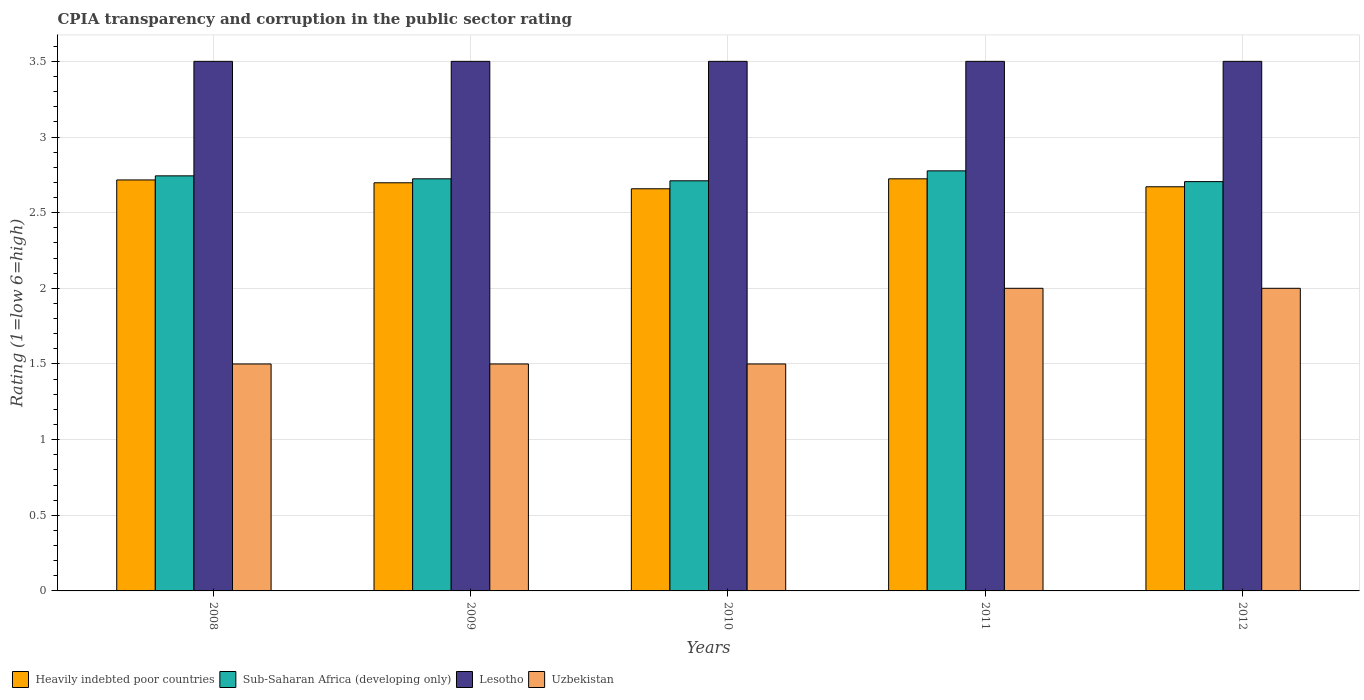How many bars are there on the 1st tick from the left?
Your answer should be compact. 4. How many bars are there on the 2nd tick from the right?
Your response must be concise. 4. What is the label of the 5th group of bars from the left?
Provide a short and direct response. 2012. What is the CPIA rating in Sub-Saharan Africa (developing only) in 2010?
Offer a very short reply. 2.71. Across all years, what is the maximum CPIA rating in Uzbekistan?
Give a very brief answer. 2. Across all years, what is the minimum CPIA rating in Uzbekistan?
Your answer should be very brief. 1.5. In which year was the CPIA rating in Heavily indebted poor countries maximum?
Provide a short and direct response. 2011. In which year was the CPIA rating in Lesotho minimum?
Provide a succinct answer. 2008. What is the total CPIA rating in Sub-Saharan Africa (developing only) in the graph?
Provide a short and direct response. 13.66. What is the difference between the CPIA rating in Lesotho in 2009 and that in 2010?
Your answer should be compact. 0. What is the difference between the CPIA rating in Uzbekistan in 2010 and the CPIA rating in Heavily indebted poor countries in 2012?
Provide a succinct answer. -1.17. What is the average CPIA rating in Heavily indebted poor countries per year?
Offer a terse response. 2.69. In the year 2012, what is the difference between the CPIA rating in Lesotho and CPIA rating in Heavily indebted poor countries?
Ensure brevity in your answer.  0.83. What is the ratio of the CPIA rating in Heavily indebted poor countries in 2010 to that in 2011?
Ensure brevity in your answer.  0.98. Is the difference between the CPIA rating in Lesotho in 2010 and 2012 greater than the difference between the CPIA rating in Heavily indebted poor countries in 2010 and 2012?
Give a very brief answer. Yes. What is the difference between the highest and the second highest CPIA rating in Heavily indebted poor countries?
Ensure brevity in your answer.  0.01. What is the difference between the highest and the lowest CPIA rating in Uzbekistan?
Ensure brevity in your answer.  0.5. Is it the case that in every year, the sum of the CPIA rating in Heavily indebted poor countries and CPIA rating in Lesotho is greater than the sum of CPIA rating in Uzbekistan and CPIA rating in Sub-Saharan Africa (developing only)?
Your answer should be compact. Yes. What does the 3rd bar from the left in 2008 represents?
Provide a succinct answer. Lesotho. What does the 4th bar from the right in 2010 represents?
Offer a very short reply. Heavily indebted poor countries. How many bars are there?
Your answer should be very brief. 20. Where does the legend appear in the graph?
Keep it short and to the point. Bottom left. How many legend labels are there?
Provide a short and direct response. 4. How are the legend labels stacked?
Ensure brevity in your answer.  Horizontal. What is the title of the graph?
Provide a succinct answer. CPIA transparency and corruption in the public sector rating. Does "Bangladesh" appear as one of the legend labels in the graph?
Offer a very short reply. No. What is the label or title of the X-axis?
Provide a short and direct response. Years. What is the Rating (1=low 6=high) in Heavily indebted poor countries in 2008?
Keep it short and to the point. 2.72. What is the Rating (1=low 6=high) of Sub-Saharan Africa (developing only) in 2008?
Keep it short and to the point. 2.74. What is the Rating (1=low 6=high) of Heavily indebted poor countries in 2009?
Ensure brevity in your answer.  2.7. What is the Rating (1=low 6=high) of Sub-Saharan Africa (developing only) in 2009?
Your answer should be compact. 2.72. What is the Rating (1=low 6=high) of Lesotho in 2009?
Offer a very short reply. 3.5. What is the Rating (1=low 6=high) of Uzbekistan in 2009?
Offer a terse response. 1.5. What is the Rating (1=low 6=high) in Heavily indebted poor countries in 2010?
Ensure brevity in your answer.  2.66. What is the Rating (1=low 6=high) of Sub-Saharan Africa (developing only) in 2010?
Ensure brevity in your answer.  2.71. What is the Rating (1=low 6=high) of Heavily indebted poor countries in 2011?
Your response must be concise. 2.72. What is the Rating (1=low 6=high) in Sub-Saharan Africa (developing only) in 2011?
Your answer should be very brief. 2.78. What is the Rating (1=low 6=high) in Heavily indebted poor countries in 2012?
Offer a very short reply. 2.67. What is the Rating (1=low 6=high) of Sub-Saharan Africa (developing only) in 2012?
Provide a short and direct response. 2.71. What is the Rating (1=low 6=high) in Lesotho in 2012?
Make the answer very short. 3.5. Across all years, what is the maximum Rating (1=low 6=high) in Heavily indebted poor countries?
Provide a short and direct response. 2.72. Across all years, what is the maximum Rating (1=low 6=high) of Sub-Saharan Africa (developing only)?
Make the answer very short. 2.78. Across all years, what is the maximum Rating (1=low 6=high) of Lesotho?
Provide a succinct answer. 3.5. Across all years, what is the minimum Rating (1=low 6=high) in Heavily indebted poor countries?
Keep it short and to the point. 2.66. Across all years, what is the minimum Rating (1=low 6=high) in Sub-Saharan Africa (developing only)?
Give a very brief answer. 2.71. Across all years, what is the minimum Rating (1=low 6=high) in Lesotho?
Your answer should be very brief. 3.5. Across all years, what is the minimum Rating (1=low 6=high) in Uzbekistan?
Ensure brevity in your answer.  1.5. What is the total Rating (1=low 6=high) of Heavily indebted poor countries in the graph?
Make the answer very short. 13.47. What is the total Rating (1=low 6=high) in Sub-Saharan Africa (developing only) in the graph?
Offer a terse response. 13.66. What is the total Rating (1=low 6=high) of Uzbekistan in the graph?
Ensure brevity in your answer.  8.5. What is the difference between the Rating (1=low 6=high) in Heavily indebted poor countries in 2008 and that in 2009?
Offer a terse response. 0.02. What is the difference between the Rating (1=low 6=high) in Sub-Saharan Africa (developing only) in 2008 and that in 2009?
Offer a terse response. 0.02. What is the difference between the Rating (1=low 6=high) of Lesotho in 2008 and that in 2009?
Ensure brevity in your answer.  0. What is the difference between the Rating (1=low 6=high) of Heavily indebted poor countries in 2008 and that in 2010?
Give a very brief answer. 0.06. What is the difference between the Rating (1=low 6=high) in Sub-Saharan Africa (developing only) in 2008 and that in 2010?
Make the answer very short. 0.03. What is the difference between the Rating (1=low 6=high) in Lesotho in 2008 and that in 2010?
Make the answer very short. 0. What is the difference between the Rating (1=low 6=high) in Uzbekistan in 2008 and that in 2010?
Make the answer very short. 0. What is the difference between the Rating (1=low 6=high) in Heavily indebted poor countries in 2008 and that in 2011?
Offer a very short reply. -0.01. What is the difference between the Rating (1=low 6=high) of Sub-Saharan Africa (developing only) in 2008 and that in 2011?
Offer a very short reply. -0.03. What is the difference between the Rating (1=low 6=high) in Lesotho in 2008 and that in 2011?
Offer a terse response. 0. What is the difference between the Rating (1=low 6=high) in Uzbekistan in 2008 and that in 2011?
Provide a succinct answer. -0.5. What is the difference between the Rating (1=low 6=high) in Heavily indebted poor countries in 2008 and that in 2012?
Provide a short and direct response. 0.05. What is the difference between the Rating (1=low 6=high) in Sub-Saharan Africa (developing only) in 2008 and that in 2012?
Your response must be concise. 0.04. What is the difference between the Rating (1=low 6=high) in Heavily indebted poor countries in 2009 and that in 2010?
Give a very brief answer. 0.04. What is the difference between the Rating (1=low 6=high) of Sub-Saharan Africa (developing only) in 2009 and that in 2010?
Give a very brief answer. 0.01. What is the difference between the Rating (1=low 6=high) of Uzbekistan in 2009 and that in 2010?
Ensure brevity in your answer.  0. What is the difference between the Rating (1=low 6=high) of Heavily indebted poor countries in 2009 and that in 2011?
Make the answer very short. -0.03. What is the difference between the Rating (1=low 6=high) in Sub-Saharan Africa (developing only) in 2009 and that in 2011?
Give a very brief answer. -0.05. What is the difference between the Rating (1=low 6=high) in Lesotho in 2009 and that in 2011?
Provide a short and direct response. 0. What is the difference between the Rating (1=low 6=high) in Heavily indebted poor countries in 2009 and that in 2012?
Provide a short and direct response. 0.03. What is the difference between the Rating (1=low 6=high) in Sub-Saharan Africa (developing only) in 2009 and that in 2012?
Offer a terse response. 0.02. What is the difference between the Rating (1=low 6=high) in Uzbekistan in 2009 and that in 2012?
Your answer should be compact. -0.5. What is the difference between the Rating (1=low 6=high) in Heavily indebted poor countries in 2010 and that in 2011?
Make the answer very short. -0.07. What is the difference between the Rating (1=low 6=high) in Sub-Saharan Africa (developing only) in 2010 and that in 2011?
Give a very brief answer. -0.07. What is the difference between the Rating (1=low 6=high) in Heavily indebted poor countries in 2010 and that in 2012?
Keep it short and to the point. -0.01. What is the difference between the Rating (1=low 6=high) of Sub-Saharan Africa (developing only) in 2010 and that in 2012?
Offer a very short reply. 0.01. What is the difference between the Rating (1=low 6=high) in Lesotho in 2010 and that in 2012?
Your answer should be very brief. 0. What is the difference between the Rating (1=low 6=high) of Heavily indebted poor countries in 2011 and that in 2012?
Offer a terse response. 0.05. What is the difference between the Rating (1=low 6=high) in Sub-Saharan Africa (developing only) in 2011 and that in 2012?
Offer a very short reply. 0.07. What is the difference between the Rating (1=low 6=high) in Lesotho in 2011 and that in 2012?
Offer a very short reply. 0. What is the difference between the Rating (1=low 6=high) in Heavily indebted poor countries in 2008 and the Rating (1=low 6=high) in Sub-Saharan Africa (developing only) in 2009?
Give a very brief answer. -0.01. What is the difference between the Rating (1=low 6=high) in Heavily indebted poor countries in 2008 and the Rating (1=low 6=high) in Lesotho in 2009?
Your response must be concise. -0.78. What is the difference between the Rating (1=low 6=high) of Heavily indebted poor countries in 2008 and the Rating (1=low 6=high) of Uzbekistan in 2009?
Provide a short and direct response. 1.22. What is the difference between the Rating (1=low 6=high) in Sub-Saharan Africa (developing only) in 2008 and the Rating (1=low 6=high) in Lesotho in 2009?
Your response must be concise. -0.76. What is the difference between the Rating (1=low 6=high) in Sub-Saharan Africa (developing only) in 2008 and the Rating (1=low 6=high) in Uzbekistan in 2009?
Provide a succinct answer. 1.24. What is the difference between the Rating (1=low 6=high) in Lesotho in 2008 and the Rating (1=low 6=high) in Uzbekistan in 2009?
Offer a very short reply. 2. What is the difference between the Rating (1=low 6=high) of Heavily indebted poor countries in 2008 and the Rating (1=low 6=high) of Sub-Saharan Africa (developing only) in 2010?
Your response must be concise. 0.01. What is the difference between the Rating (1=low 6=high) in Heavily indebted poor countries in 2008 and the Rating (1=low 6=high) in Lesotho in 2010?
Ensure brevity in your answer.  -0.78. What is the difference between the Rating (1=low 6=high) of Heavily indebted poor countries in 2008 and the Rating (1=low 6=high) of Uzbekistan in 2010?
Give a very brief answer. 1.22. What is the difference between the Rating (1=low 6=high) of Sub-Saharan Africa (developing only) in 2008 and the Rating (1=low 6=high) of Lesotho in 2010?
Offer a terse response. -0.76. What is the difference between the Rating (1=low 6=high) in Sub-Saharan Africa (developing only) in 2008 and the Rating (1=low 6=high) in Uzbekistan in 2010?
Ensure brevity in your answer.  1.24. What is the difference between the Rating (1=low 6=high) of Lesotho in 2008 and the Rating (1=low 6=high) of Uzbekistan in 2010?
Provide a succinct answer. 2. What is the difference between the Rating (1=low 6=high) in Heavily indebted poor countries in 2008 and the Rating (1=low 6=high) in Sub-Saharan Africa (developing only) in 2011?
Offer a very short reply. -0.06. What is the difference between the Rating (1=low 6=high) in Heavily indebted poor countries in 2008 and the Rating (1=low 6=high) in Lesotho in 2011?
Provide a short and direct response. -0.78. What is the difference between the Rating (1=low 6=high) of Heavily indebted poor countries in 2008 and the Rating (1=low 6=high) of Uzbekistan in 2011?
Offer a very short reply. 0.72. What is the difference between the Rating (1=low 6=high) of Sub-Saharan Africa (developing only) in 2008 and the Rating (1=low 6=high) of Lesotho in 2011?
Provide a short and direct response. -0.76. What is the difference between the Rating (1=low 6=high) in Sub-Saharan Africa (developing only) in 2008 and the Rating (1=low 6=high) in Uzbekistan in 2011?
Ensure brevity in your answer.  0.74. What is the difference between the Rating (1=low 6=high) of Lesotho in 2008 and the Rating (1=low 6=high) of Uzbekistan in 2011?
Your response must be concise. 1.5. What is the difference between the Rating (1=low 6=high) in Heavily indebted poor countries in 2008 and the Rating (1=low 6=high) in Sub-Saharan Africa (developing only) in 2012?
Offer a very short reply. 0.01. What is the difference between the Rating (1=low 6=high) of Heavily indebted poor countries in 2008 and the Rating (1=low 6=high) of Lesotho in 2012?
Provide a short and direct response. -0.78. What is the difference between the Rating (1=low 6=high) in Heavily indebted poor countries in 2008 and the Rating (1=low 6=high) in Uzbekistan in 2012?
Provide a short and direct response. 0.72. What is the difference between the Rating (1=low 6=high) in Sub-Saharan Africa (developing only) in 2008 and the Rating (1=low 6=high) in Lesotho in 2012?
Ensure brevity in your answer.  -0.76. What is the difference between the Rating (1=low 6=high) in Sub-Saharan Africa (developing only) in 2008 and the Rating (1=low 6=high) in Uzbekistan in 2012?
Provide a succinct answer. 0.74. What is the difference between the Rating (1=low 6=high) of Lesotho in 2008 and the Rating (1=low 6=high) of Uzbekistan in 2012?
Provide a short and direct response. 1.5. What is the difference between the Rating (1=low 6=high) of Heavily indebted poor countries in 2009 and the Rating (1=low 6=high) of Sub-Saharan Africa (developing only) in 2010?
Offer a very short reply. -0.01. What is the difference between the Rating (1=low 6=high) of Heavily indebted poor countries in 2009 and the Rating (1=low 6=high) of Lesotho in 2010?
Keep it short and to the point. -0.8. What is the difference between the Rating (1=low 6=high) of Heavily indebted poor countries in 2009 and the Rating (1=low 6=high) of Uzbekistan in 2010?
Make the answer very short. 1.2. What is the difference between the Rating (1=low 6=high) of Sub-Saharan Africa (developing only) in 2009 and the Rating (1=low 6=high) of Lesotho in 2010?
Ensure brevity in your answer.  -0.78. What is the difference between the Rating (1=low 6=high) in Sub-Saharan Africa (developing only) in 2009 and the Rating (1=low 6=high) in Uzbekistan in 2010?
Ensure brevity in your answer.  1.22. What is the difference between the Rating (1=low 6=high) in Lesotho in 2009 and the Rating (1=low 6=high) in Uzbekistan in 2010?
Ensure brevity in your answer.  2. What is the difference between the Rating (1=low 6=high) of Heavily indebted poor countries in 2009 and the Rating (1=low 6=high) of Sub-Saharan Africa (developing only) in 2011?
Provide a short and direct response. -0.08. What is the difference between the Rating (1=low 6=high) of Heavily indebted poor countries in 2009 and the Rating (1=low 6=high) of Lesotho in 2011?
Your answer should be compact. -0.8. What is the difference between the Rating (1=low 6=high) in Heavily indebted poor countries in 2009 and the Rating (1=low 6=high) in Uzbekistan in 2011?
Provide a succinct answer. 0.7. What is the difference between the Rating (1=low 6=high) of Sub-Saharan Africa (developing only) in 2009 and the Rating (1=low 6=high) of Lesotho in 2011?
Your response must be concise. -0.78. What is the difference between the Rating (1=low 6=high) in Sub-Saharan Africa (developing only) in 2009 and the Rating (1=low 6=high) in Uzbekistan in 2011?
Your response must be concise. 0.72. What is the difference between the Rating (1=low 6=high) of Heavily indebted poor countries in 2009 and the Rating (1=low 6=high) of Sub-Saharan Africa (developing only) in 2012?
Your answer should be very brief. -0.01. What is the difference between the Rating (1=low 6=high) of Heavily indebted poor countries in 2009 and the Rating (1=low 6=high) of Lesotho in 2012?
Ensure brevity in your answer.  -0.8. What is the difference between the Rating (1=low 6=high) in Heavily indebted poor countries in 2009 and the Rating (1=low 6=high) in Uzbekistan in 2012?
Make the answer very short. 0.7. What is the difference between the Rating (1=low 6=high) in Sub-Saharan Africa (developing only) in 2009 and the Rating (1=low 6=high) in Lesotho in 2012?
Give a very brief answer. -0.78. What is the difference between the Rating (1=low 6=high) of Sub-Saharan Africa (developing only) in 2009 and the Rating (1=low 6=high) of Uzbekistan in 2012?
Ensure brevity in your answer.  0.72. What is the difference between the Rating (1=low 6=high) of Heavily indebted poor countries in 2010 and the Rating (1=low 6=high) of Sub-Saharan Africa (developing only) in 2011?
Make the answer very short. -0.12. What is the difference between the Rating (1=low 6=high) in Heavily indebted poor countries in 2010 and the Rating (1=low 6=high) in Lesotho in 2011?
Your response must be concise. -0.84. What is the difference between the Rating (1=low 6=high) in Heavily indebted poor countries in 2010 and the Rating (1=low 6=high) in Uzbekistan in 2011?
Your answer should be very brief. 0.66. What is the difference between the Rating (1=low 6=high) in Sub-Saharan Africa (developing only) in 2010 and the Rating (1=low 6=high) in Lesotho in 2011?
Provide a succinct answer. -0.79. What is the difference between the Rating (1=low 6=high) in Sub-Saharan Africa (developing only) in 2010 and the Rating (1=low 6=high) in Uzbekistan in 2011?
Your answer should be compact. 0.71. What is the difference between the Rating (1=low 6=high) in Heavily indebted poor countries in 2010 and the Rating (1=low 6=high) in Sub-Saharan Africa (developing only) in 2012?
Ensure brevity in your answer.  -0.05. What is the difference between the Rating (1=low 6=high) of Heavily indebted poor countries in 2010 and the Rating (1=low 6=high) of Lesotho in 2012?
Provide a succinct answer. -0.84. What is the difference between the Rating (1=low 6=high) in Heavily indebted poor countries in 2010 and the Rating (1=low 6=high) in Uzbekistan in 2012?
Offer a terse response. 0.66. What is the difference between the Rating (1=low 6=high) of Sub-Saharan Africa (developing only) in 2010 and the Rating (1=low 6=high) of Lesotho in 2012?
Ensure brevity in your answer.  -0.79. What is the difference between the Rating (1=low 6=high) of Sub-Saharan Africa (developing only) in 2010 and the Rating (1=low 6=high) of Uzbekistan in 2012?
Provide a short and direct response. 0.71. What is the difference between the Rating (1=low 6=high) of Lesotho in 2010 and the Rating (1=low 6=high) of Uzbekistan in 2012?
Your answer should be compact. 1.5. What is the difference between the Rating (1=low 6=high) in Heavily indebted poor countries in 2011 and the Rating (1=low 6=high) in Sub-Saharan Africa (developing only) in 2012?
Make the answer very short. 0.02. What is the difference between the Rating (1=low 6=high) in Heavily indebted poor countries in 2011 and the Rating (1=low 6=high) in Lesotho in 2012?
Provide a short and direct response. -0.78. What is the difference between the Rating (1=low 6=high) of Heavily indebted poor countries in 2011 and the Rating (1=low 6=high) of Uzbekistan in 2012?
Your answer should be very brief. 0.72. What is the difference between the Rating (1=low 6=high) of Sub-Saharan Africa (developing only) in 2011 and the Rating (1=low 6=high) of Lesotho in 2012?
Your answer should be compact. -0.72. What is the difference between the Rating (1=low 6=high) in Sub-Saharan Africa (developing only) in 2011 and the Rating (1=low 6=high) in Uzbekistan in 2012?
Keep it short and to the point. 0.78. What is the difference between the Rating (1=low 6=high) of Lesotho in 2011 and the Rating (1=low 6=high) of Uzbekistan in 2012?
Provide a short and direct response. 1.5. What is the average Rating (1=low 6=high) of Heavily indebted poor countries per year?
Provide a succinct answer. 2.69. What is the average Rating (1=low 6=high) in Sub-Saharan Africa (developing only) per year?
Your answer should be very brief. 2.73. In the year 2008, what is the difference between the Rating (1=low 6=high) of Heavily indebted poor countries and Rating (1=low 6=high) of Sub-Saharan Africa (developing only)?
Give a very brief answer. -0.03. In the year 2008, what is the difference between the Rating (1=low 6=high) in Heavily indebted poor countries and Rating (1=low 6=high) in Lesotho?
Keep it short and to the point. -0.78. In the year 2008, what is the difference between the Rating (1=low 6=high) in Heavily indebted poor countries and Rating (1=low 6=high) in Uzbekistan?
Provide a short and direct response. 1.22. In the year 2008, what is the difference between the Rating (1=low 6=high) of Sub-Saharan Africa (developing only) and Rating (1=low 6=high) of Lesotho?
Provide a succinct answer. -0.76. In the year 2008, what is the difference between the Rating (1=low 6=high) of Sub-Saharan Africa (developing only) and Rating (1=low 6=high) of Uzbekistan?
Give a very brief answer. 1.24. In the year 2009, what is the difference between the Rating (1=low 6=high) in Heavily indebted poor countries and Rating (1=low 6=high) in Sub-Saharan Africa (developing only)?
Ensure brevity in your answer.  -0.03. In the year 2009, what is the difference between the Rating (1=low 6=high) of Heavily indebted poor countries and Rating (1=low 6=high) of Lesotho?
Your response must be concise. -0.8. In the year 2009, what is the difference between the Rating (1=low 6=high) of Heavily indebted poor countries and Rating (1=low 6=high) of Uzbekistan?
Keep it short and to the point. 1.2. In the year 2009, what is the difference between the Rating (1=low 6=high) of Sub-Saharan Africa (developing only) and Rating (1=low 6=high) of Lesotho?
Make the answer very short. -0.78. In the year 2009, what is the difference between the Rating (1=low 6=high) of Sub-Saharan Africa (developing only) and Rating (1=low 6=high) of Uzbekistan?
Provide a short and direct response. 1.22. In the year 2009, what is the difference between the Rating (1=low 6=high) in Lesotho and Rating (1=low 6=high) in Uzbekistan?
Your answer should be very brief. 2. In the year 2010, what is the difference between the Rating (1=low 6=high) in Heavily indebted poor countries and Rating (1=low 6=high) in Sub-Saharan Africa (developing only)?
Ensure brevity in your answer.  -0.05. In the year 2010, what is the difference between the Rating (1=low 6=high) of Heavily indebted poor countries and Rating (1=low 6=high) of Lesotho?
Offer a terse response. -0.84. In the year 2010, what is the difference between the Rating (1=low 6=high) in Heavily indebted poor countries and Rating (1=low 6=high) in Uzbekistan?
Your response must be concise. 1.16. In the year 2010, what is the difference between the Rating (1=low 6=high) of Sub-Saharan Africa (developing only) and Rating (1=low 6=high) of Lesotho?
Your response must be concise. -0.79. In the year 2010, what is the difference between the Rating (1=low 6=high) of Sub-Saharan Africa (developing only) and Rating (1=low 6=high) of Uzbekistan?
Provide a succinct answer. 1.21. In the year 2010, what is the difference between the Rating (1=low 6=high) of Lesotho and Rating (1=low 6=high) of Uzbekistan?
Keep it short and to the point. 2. In the year 2011, what is the difference between the Rating (1=low 6=high) in Heavily indebted poor countries and Rating (1=low 6=high) in Sub-Saharan Africa (developing only)?
Ensure brevity in your answer.  -0.05. In the year 2011, what is the difference between the Rating (1=low 6=high) of Heavily indebted poor countries and Rating (1=low 6=high) of Lesotho?
Ensure brevity in your answer.  -0.78. In the year 2011, what is the difference between the Rating (1=low 6=high) in Heavily indebted poor countries and Rating (1=low 6=high) in Uzbekistan?
Give a very brief answer. 0.72. In the year 2011, what is the difference between the Rating (1=low 6=high) in Sub-Saharan Africa (developing only) and Rating (1=low 6=high) in Lesotho?
Your response must be concise. -0.72. In the year 2011, what is the difference between the Rating (1=low 6=high) of Sub-Saharan Africa (developing only) and Rating (1=low 6=high) of Uzbekistan?
Make the answer very short. 0.78. In the year 2012, what is the difference between the Rating (1=low 6=high) of Heavily indebted poor countries and Rating (1=low 6=high) of Sub-Saharan Africa (developing only)?
Give a very brief answer. -0.03. In the year 2012, what is the difference between the Rating (1=low 6=high) in Heavily indebted poor countries and Rating (1=low 6=high) in Lesotho?
Offer a terse response. -0.83. In the year 2012, what is the difference between the Rating (1=low 6=high) in Heavily indebted poor countries and Rating (1=low 6=high) in Uzbekistan?
Offer a terse response. 0.67. In the year 2012, what is the difference between the Rating (1=low 6=high) of Sub-Saharan Africa (developing only) and Rating (1=low 6=high) of Lesotho?
Your response must be concise. -0.79. In the year 2012, what is the difference between the Rating (1=low 6=high) of Sub-Saharan Africa (developing only) and Rating (1=low 6=high) of Uzbekistan?
Your response must be concise. 0.71. In the year 2012, what is the difference between the Rating (1=low 6=high) in Lesotho and Rating (1=low 6=high) in Uzbekistan?
Provide a short and direct response. 1.5. What is the ratio of the Rating (1=low 6=high) of Lesotho in 2008 to that in 2009?
Ensure brevity in your answer.  1. What is the ratio of the Rating (1=low 6=high) of Uzbekistan in 2008 to that in 2009?
Give a very brief answer. 1. What is the ratio of the Rating (1=low 6=high) of Heavily indebted poor countries in 2008 to that in 2010?
Give a very brief answer. 1.02. What is the ratio of the Rating (1=low 6=high) in Sub-Saharan Africa (developing only) in 2008 to that in 2010?
Provide a succinct answer. 1.01. What is the ratio of the Rating (1=low 6=high) in Lesotho in 2008 to that in 2010?
Offer a terse response. 1. What is the ratio of the Rating (1=low 6=high) of Lesotho in 2008 to that in 2011?
Offer a very short reply. 1. What is the ratio of the Rating (1=low 6=high) of Heavily indebted poor countries in 2008 to that in 2012?
Provide a succinct answer. 1.02. What is the ratio of the Rating (1=low 6=high) in Sub-Saharan Africa (developing only) in 2008 to that in 2012?
Your answer should be compact. 1.01. What is the ratio of the Rating (1=low 6=high) of Lesotho in 2008 to that in 2012?
Ensure brevity in your answer.  1. What is the ratio of the Rating (1=low 6=high) of Heavily indebted poor countries in 2009 to that in 2010?
Provide a short and direct response. 1.01. What is the ratio of the Rating (1=low 6=high) of Sub-Saharan Africa (developing only) in 2009 to that in 2010?
Provide a short and direct response. 1. What is the ratio of the Rating (1=low 6=high) of Lesotho in 2009 to that in 2010?
Offer a very short reply. 1. What is the ratio of the Rating (1=low 6=high) in Heavily indebted poor countries in 2009 to that in 2011?
Your answer should be compact. 0.99. What is the ratio of the Rating (1=low 6=high) in Sub-Saharan Africa (developing only) in 2009 to that in 2011?
Ensure brevity in your answer.  0.98. What is the ratio of the Rating (1=low 6=high) of Uzbekistan in 2009 to that in 2011?
Offer a very short reply. 0.75. What is the ratio of the Rating (1=low 6=high) in Heavily indebted poor countries in 2009 to that in 2012?
Keep it short and to the point. 1.01. What is the ratio of the Rating (1=low 6=high) in Heavily indebted poor countries in 2010 to that in 2011?
Give a very brief answer. 0.98. What is the ratio of the Rating (1=low 6=high) in Sub-Saharan Africa (developing only) in 2010 to that in 2011?
Ensure brevity in your answer.  0.98. What is the ratio of the Rating (1=low 6=high) in Sub-Saharan Africa (developing only) in 2010 to that in 2012?
Provide a succinct answer. 1. What is the ratio of the Rating (1=low 6=high) in Lesotho in 2010 to that in 2012?
Your answer should be very brief. 1. What is the ratio of the Rating (1=low 6=high) of Heavily indebted poor countries in 2011 to that in 2012?
Offer a very short reply. 1.02. What is the ratio of the Rating (1=low 6=high) of Sub-Saharan Africa (developing only) in 2011 to that in 2012?
Give a very brief answer. 1.03. What is the difference between the highest and the second highest Rating (1=low 6=high) of Heavily indebted poor countries?
Make the answer very short. 0.01. What is the difference between the highest and the second highest Rating (1=low 6=high) in Sub-Saharan Africa (developing only)?
Make the answer very short. 0.03. What is the difference between the highest and the second highest Rating (1=low 6=high) of Lesotho?
Your answer should be very brief. 0. What is the difference between the highest and the lowest Rating (1=low 6=high) of Heavily indebted poor countries?
Give a very brief answer. 0.07. What is the difference between the highest and the lowest Rating (1=low 6=high) of Sub-Saharan Africa (developing only)?
Provide a succinct answer. 0.07. What is the difference between the highest and the lowest Rating (1=low 6=high) in Lesotho?
Provide a short and direct response. 0. What is the difference between the highest and the lowest Rating (1=low 6=high) of Uzbekistan?
Make the answer very short. 0.5. 